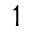<formula> <loc_0><loc_0><loc_500><loc_500>^ { 1 }</formula> 